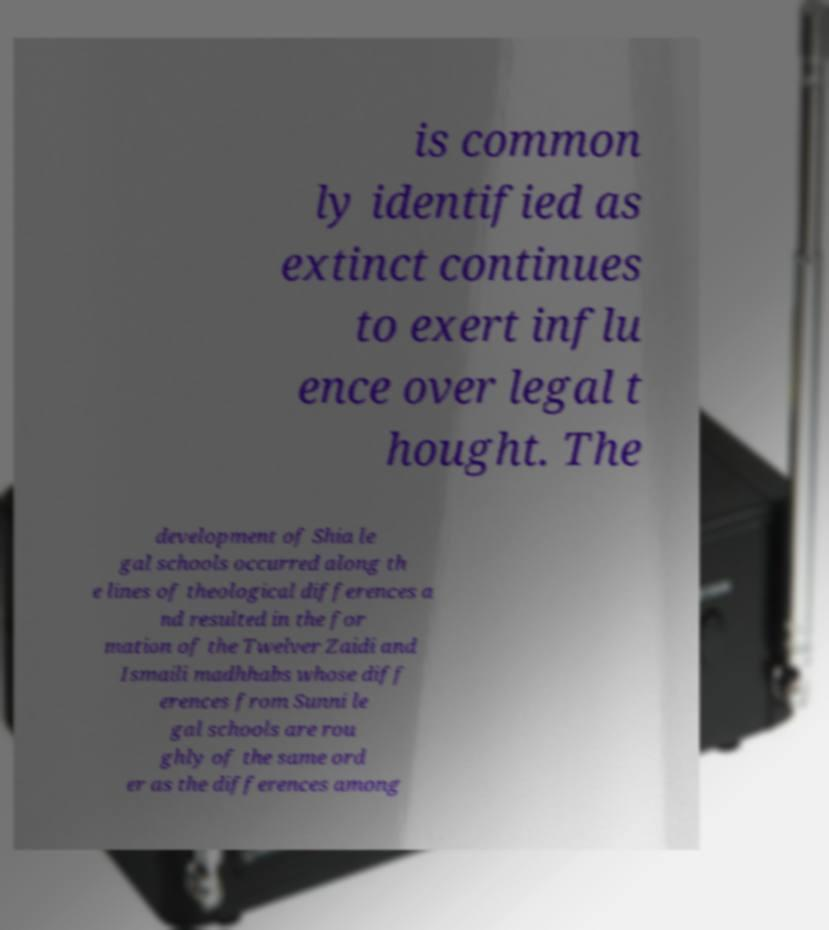What messages or text are displayed in this image? I need them in a readable, typed format. is common ly identified as extinct continues to exert influ ence over legal t hought. The development of Shia le gal schools occurred along th e lines of theological differences a nd resulted in the for mation of the Twelver Zaidi and Ismaili madhhabs whose diff erences from Sunni le gal schools are rou ghly of the same ord er as the differences among 